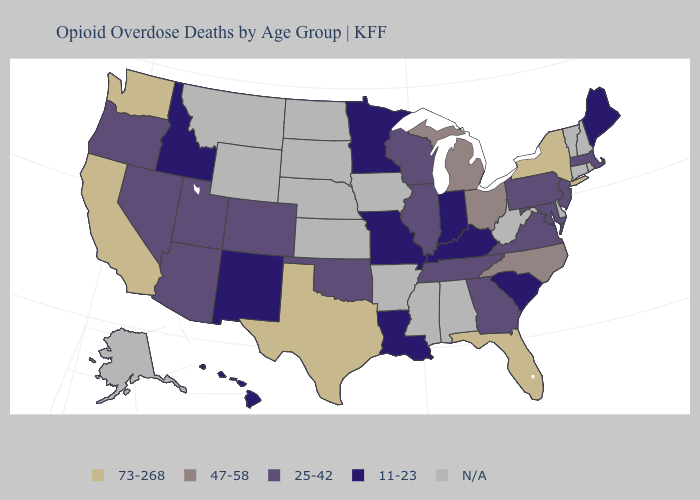Name the states that have a value in the range N/A?
Write a very short answer. Alabama, Alaska, Arkansas, Connecticut, Delaware, Iowa, Kansas, Mississippi, Montana, Nebraska, New Hampshire, North Dakota, Rhode Island, South Dakota, Vermont, West Virginia, Wyoming. Name the states that have a value in the range 47-58?
Short answer required. Michigan, North Carolina, Ohio. Name the states that have a value in the range N/A?
Keep it brief. Alabama, Alaska, Arkansas, Connecticut, Delaware, Iowa, Kansas, Mississippi, Montana, Nebraska, New Hampshire, North Dakota, Rhode Island, South Dakota, Vermont, West Virginia, Wyoming. Name the states that have a value in the range N/A?
Answer briefly. Alabama, Alaska, Arkansas, Connecticut, Delaware, Iowa, Kansas, Mississippi, Montana, Nebraska, New Hampshire, North Dakota, Rhode Island, South Dakota, Vermont, West Virginia, Wyoming. Is the legend a continuous bar?
Answer briefly. No. What is the value of Nebraska?
Be succinct. N/A. What is the value of Maryland?
Write a very short answer. 25-42. What is the highest value in the Northeast ?
Answer briefly. 73-268. Which states have the lowest value in the USA?
Keep it brief. Hawaii, Idaho, Indiana, Kentucky, Louisiana, Maine, Minnesota, Missouri, New Mexico, South Carolina. Does Kentucky have the lowest value in the USA?
Answer briefly. Yes. What is the value of Rhode Island?
Keep it brief. N/A. Name the states that have a value in the range 73-268?
Quick response, please. California, Florida, New York, Texas, Washington. Name the states that have a value in the range 25-42?
Answer briefly. Arizona, Colorado, Georgia, Illinois, Maryland, Massachusetts, Nevada, New Jersey, Oklahoma, Oregon, Pennsylvania, Tennessee, Utah, Virginia, Wisconsin. What is the value of Oklahoma?
Concise answer only. 25-42. 